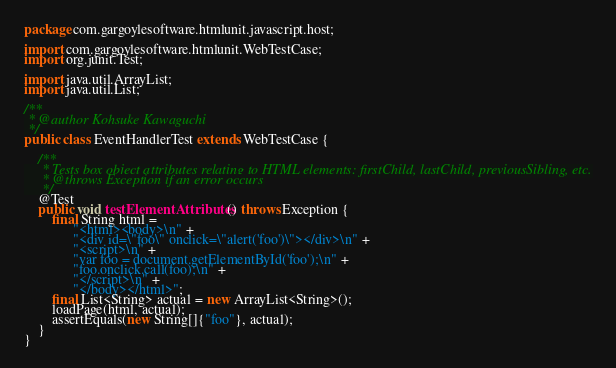Convert code to text. <code><loc_0><loc_0><loc_500><loc_500><_Java_>package com.gargoylesoftware.htmlunit.javascript.host;

import com.gargoylesoftware.htmlunit.WebTestCase;
import org.junit.Test;

import java.util.ArrayList;
import java.util.List;

/**
 * @author Kohsuke Kawaguchi
 */
public class EventHandlerTest extends WebTestCase {

    /**
     * Tests box object attributes relating to HTML elements: firstChild, lastChild, previousSibling, etc.
     * @throws Exception if an error occurs
     */
    @Test
    public void testElementAttributes() throws Exception {
        final String html =
              "<html><body>\n" +
              "<div id=\"foo\" onclick=\"alert('foo')\"></div>\n" +
              "<script>\n" +
              "var foo = document.getElementById('foo');\n" +
              "foo.onclick.call(foo);\n" +
              "</script>\n" +
              "</body></html>";
        final List<String> actual = new ArrayList<String>();
        loadPage(html, actual);
        assertEquals(new String[]{"foo"}, actual);
    }
}</code> 